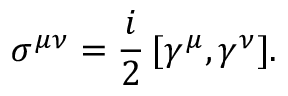Convert formula to latex. <formula><loc_0><loc_0><loc_500><loc_500>\sigma ^ { \mu \nu } = \frac { i } { 2 } \, [ \gamma ^ { \mu } , \gamma ^ { \nu } ] .</formula> 